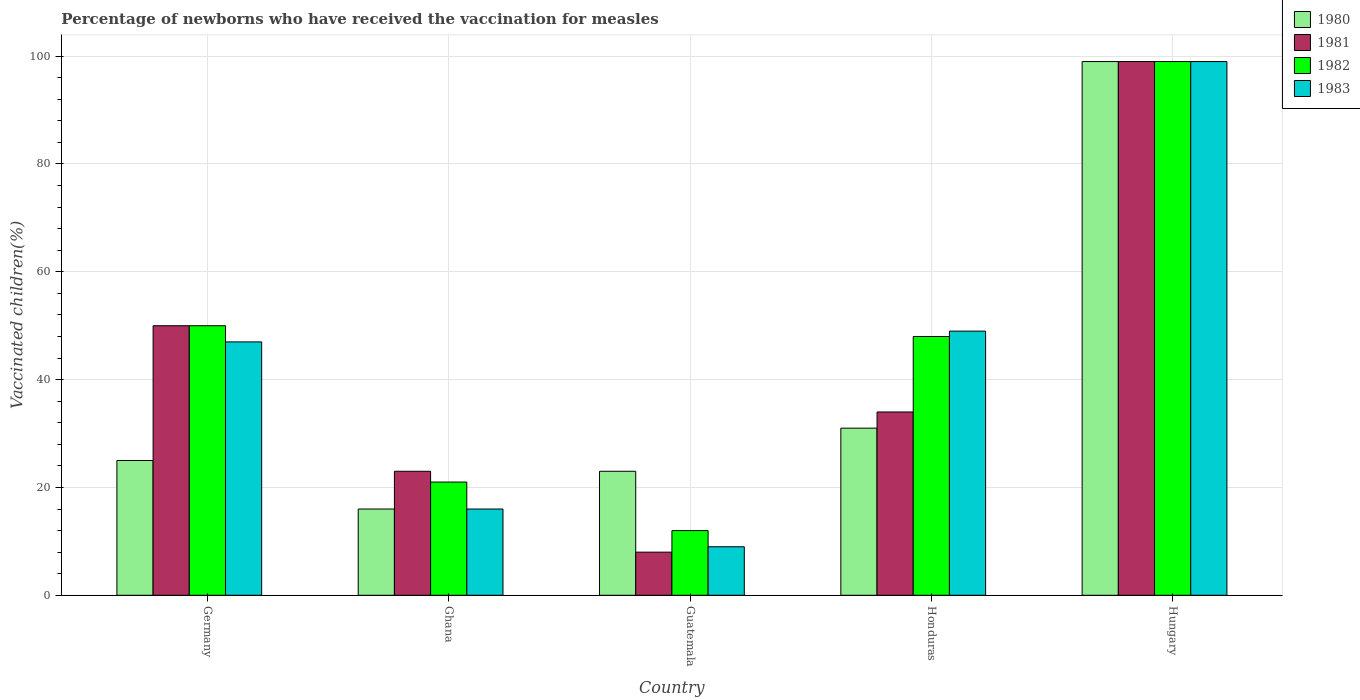How many different coloured bars are there?
Provide a succinct answer. 4. How many groups of bars are there?
Your response must be concise. 5. Are the number of bars per tick equal to the number of legend labels?
Provide a short and direct response. Yes. How many bars are there on the 5th tick from the left?
Offer a terse response. 4. How many bars are there on the 5th tick from the right?
Give a very brief answer. 4. What is the label of the 5th group of bars from the left?
Provide a succinct answer. Hungary. What is the percentage of vaccinated children in 1983 in Germany?
Your answer should be compact. 47. Across all countries, what is the maximum percentage of vaccinated children in 1981?
Give a very brief answer. 99. Across all countries, what is the minimum percentage of vaccinated children in 1983?
Provide a succinct answer. 9. In which country was the percentage of vaccinated children in 1982 maximum?
Provide a succinct answer. Hungary. In which country was the percentage of vaccinated children in 1981 minimum?
Offer a terse response. Guatemala. What is the total percentage of vaccinated children in 1982 in the graph?
Your answer should be very brief. 230. What is the difference between the percentage of vaccinated children in 1980 in Honduras and that in Hungary?
Keep it short and to the point. -68. What is the average percentage of vaccinated children in 1983 per country?
Offer a terse response. 44. What is the difference between the percentage of vaccinated children of/in 1982 and percentage of vaccinated children of/in 1980 in Honduras?
Give a very brief answer. 17. What is the ratio of the percentage of vaccinated children in 1980 in Honduras to that in Hungary?
Offer a very short reply. 0.31. In how many countries, is the percentage of vaccinated children in 1981 greater than the average percentage of vaccinated children in 1981 taken over all countries?
Ensure brevity in your answer.  2. What does the 4th bar from the left in Guatemala represents?
Your response must be concise. 1983. Is it the case that in every country, the sum of the percentage of vaccinated children in 1982 and percentage of vaccinated children in 1983 is greater than the percentage of vaccinated children in 1981?
Keep it short and to the point. Yes. Are the values on the major ticks of Y-axis written in scientific E-notation?
Your response must be concise. No. Does the graph contain grids?
Ensure brevity in your answer.  Yes. Where does the legend appear in the graph?
Provide a succinct answer. Top right. What is the title of the graph?
Your answer should be very brief. Percentage of newborns who have received the vaccination for measles. What is the label or title of the Y-axis?
Your answer should be very brief. Vaccinated children(%). What is the Vaccinated children(%) of 1980 in Germany?
Your response must be concise. 25. What is the Vaccinated children(%) in 1982 in Germany?
Provide a succinct answer. 50. What is the Vaccinated children(%) of 1983 in Germany?
Keep it short and to the point. 47. What is the Vaccinated children(%) in 1981 in Ghana?
Keep it short and to the point. 23. What is the Vaccinated children(%) in 1982 in Ghana?
Ensure brevity in your answer.  21. What is the Vaccinated children(%) of 1980 in Guatemala?
Make the answer very short. 23. What is the Vaccinated children(%) of 1981 in Honduras?
Your answer should be compact. 34. What is the Vaccinated children(%) of 1982 in Honduras?
Your response must be concise. 48. What is the Vaccinated children(%) of 1980 in Hungary?
Offer a terse response. 99. What is the Vaccinated children(%) of 1981 in Hungary?
Provide a succinct answer. 99. What is the Vaccinated children(%) in 1982 in Hungary?
Offer a terse response. 99. Across all countries, what is the maximum Vaccinated children(%) of 1981?
Make the answer very short. 99. Across all countries, what is the maximum Vaccinated children(%) in 1983?
Offer a terse response. 99. Across all countries, what is the minimum Vaccinated children(%) of 1980?
Keep it short and to the point. 16. Across all countries, what is the minimum Vaccinated children(%) in 1982?
Your answer should be compact. 12. Across all countries, what is the minimum Vaccinated children(%) in 1983?
Provide a short and direct response. 9. What is the total Vaccinated children(%) of 1980 in the graph?
Keep it short and to the point. 194. What is the total Vaccinated children(%) in 1981 in the graph?
Your response must be concise. 214. What is the total Vaccinated children(%) of 1982 in the graph?
Provide a succinct answer. 230. What is the total Vaccinated children(%) of 1983 in the graph?
Offer a very short reply. 220. What is the difference between the Vaccinated children(%) in 1981 in Germany and that in Ghana?
Keep it short and to the point. 27. What is the difference between the Vaccinated children(%) of 1983 in Germany and that in Ghana?
Make the answer very short. 31. What is the difference between the Vaccinated children(%) in 1980 in Germany and that in Honduras?
Offer a very short reply. -6. What is the difference between the Vaccinated children(%) of 1981 in Germany and that in Honduras?
Your answer should be very brief. 16. What is the difference between the Vaccinated children(%) of 1982 in Germany and that in Honduras?
Give a very brief answer. 2. What is the difference between the Vaccinated children(%) of 1983 in Germany and that in Honduras?
Your answer should be very brief. -2. What is the difference between the Vaccinated children(%) of 1980 in Germany and that in Hungary?
Give a very brief answer. -74. What is the difference between the Vaccinated children(%) of 1981 in Germany and that in Hungary?
Provide a short and direct response. -49. What is the difference between the Vaccinated children(%) in 1982 in Germany and that in Hungary?
Provide a short and direct response. -49. What is the difference between the Vaccinated children(%) of 1983 in Germany and that in Hungary?
Ensure brevity in your answer.  -52. What is the difference between the Vaccinated children(%) of 1980 in Ghana and that in Honduras?
Ensure brevity in your answer.  -15. What is the difference between the Vaccinated children(%) in 1981 in Ghana and that in Honduras?
Your answer should be compact. -11. What is the difference between the Vaccinated children(%) of 1982 in Ghana and that in Honduras?
Provide a succinct answer. -27. What is the difference between the Vaccinated children(%) in 1983 in Ghana and that in Honduras?
Ensure brevity in your answer.  -33. What is the difference between the Vaccinated children(%) in 1980 in Ghana and that in Hungary?
Provide a short and direct response. -83. What is the difference between the Vaccinated children(%) in 1981 in Ghana and that in Hungary?
Provide a succinct answer. -76. What is the difference between the Vaccinated children(%) in 1982 in Ghana and that in Hungary?
Give a very brief answer. -78. What is the difference between the Vaccinated children(%) of 1983 in Ghana and that in Hungary?
Give a very brief answer. -83. What is the difference between the Vaccinated children(%) of 1982 in Guatemala and that in Honduras?
Offer a terse response. -36. What is the difference between the Vaccinated children(%) in 1980 in Guatemala and that in Hungary?
Your answer should be compact. -76. What is the difference between the Vaccinated children(%) of 1981 in Guatemala and that in Hungary?
Make the answer very short. -91. What is the difference between the Vaccinated children(%) of 1982 in Guatemala and that in Hungary?
Offer a terse response. -87. What is the difference between the Vaccinated children(%) of 1983 in Guatemala and that in Hungary?
Provide a succinct answer. -90. What is the difference between the Vaccinated children(%) in 1980 in Honduras and that in Hungary?
Provide a short and direct response. -68. What is the difference between the Vaccinated children(%) of 1981 in Honduras and that in Hungary?
Your answer should be compact. -65. What is the difference between the Vaccinated children(%) in 1982 in Honduras and that in Hungary?
Keep it short and to the point. -51. What is the difference between the Vaccinated children(%) of 1983 in Honduras and that in Hungary?
Your answer should be compact. -50. What is the difference between the Vaccinated children(%) in 1980 in Germany and the Vaccinated children(%) in 1982 in Ghana?
Ensure brevity in your answer.  4. What is the difference between the Vaccinated children(%) in 1981 in Germany and the Vaccinated children(%) in 1982 in Ghana?
Provide a succinct answer. 29. What is the difference between the Vaccinated children(%) of 1982 in Germany and the Vaccinated children(%) of 1983 in Ghana?
Offer a terse response. 34. What is the difference between the Vaccinated children(%) in 1980 in Germany and the Vaccinated children(%) in 1982 in Guatemala?
Your response must be concise. 13. What is the difference between the Vaccinated children(%) of 1981 in Germany and the Vaccinated children(%) of 1982 in Guatemala?
Provide a succinct answer. 38. What is the difference between the Vaccinated children(%) of 1982 in Germany and the Vaccinated children(%) of 1983 in Guatemala?
Your answer should be compact. 41. What is the difference between the Vaccinated children(%) of 1980 in Germany and the Vaccinated children(%) of 1982 in Honduras?
Provide a succinct answer. -23. What is the difference between the Vaccinated children(%) in 1980 in Germany and the Vaccinated children(%) in 1983 in Honduras?
Provide a short and direct response. -24. What is the difference between the Vaccinated children(%) in 1981 in Germany and the Vaccinated children(%) in 1982 in Honduras?
Provide a short and direct response. 2. What is the difference between the Vaccinated children(%) of 1980 in Germany and the Vaccinated children(%) of 1981 in Hungary?
Your answer should be compact. -74. What is the difference between the Vaccinated children(%) in 1980 in Germany and the Vaccinated children(%) in 1982 in Hungary?
Your response must be concise. -74. What is the difference between the Vaccinated children(%) in 1980 in Germany and the Vaccinated children(%) in 1983 in Hungary?
Offer a very short reply. -74. What is the difference between the Vaccinated children(%) of 1981 in Germany and the Vaccinated children(%) of 1982 in Hungary?
Offer a terse response. -49. What is the difference between the Vaccinated children(%) of 1981 in Germany and the Vaccinated children(%) of 1983 in Hungary?
Provide a short and direct response. -49. What is the difference between the Vaccinated children(%) in 1982 in Germany and the Vaccinated children(%) in 1983 in Hungary?
Your response must be concise. -49. What is the difference between the Vaccinated children(%) of 1980 in Ghana and the Vaccinated children(%) of 1981 in Guatemala?
Your answer should be compact. 8. What is the difference between the Vaccinated children(%) in 1980 in Ghana and the Vaccinated children(%) in 1982 in Guatemala?
Make the answer very short. 4. What is the difference between the Vaccinated children(%) of 1981 in Ghana and the Vaccinated children(%) of 1982 in Guatemala?
Your answer should be compact. 11. What is the difference between the Vaccinated children(%) in 1981 in Ghana and the Vaccinated children(%) in 1983 in Guatemala?
Your answer should be very brief. 14. What is the difference between the Vaccinated children(%) of 1982 in Ghana and the Vaccinated children(%) of 1983 in Guatemala?
Offer a terse response. 12. What is the difference between the Vaccinated children(%) of 1980 in Ghana and the Vaccinated children(%) of 1982 in Honduras?
Your answer should be very brief. -32. What is the difference between the Vaccinated children(%) in 1980 in Ghana and the Vaccinated children(%) in 1983 in Honduras?
Offer a very short reply. -33. What is the difference between the Vaccinated children(%) in 1981 in Ghana and the Vaccinated children(%) in 1982 in Honduras?
Your response must be concise. -25. What is the difference between the Vaccinated children(%) of 1981 in Ghana and the Vaccinated children(%) of 1983 in Honduras?
Provide a succinct answer. -26. What is the difference between the Vaccinated children(%) of 1982 in Ghana and the Vaccinated children(%) of 1983 in Honduras?
Offer a very short reply. -28. What is the difference between the Vaccinated children(%) of 1980 in Ghana and the Vaccinated children(%) of 1981 in Hungary?
Your answer should be compact. -83. What is the difference between the Vaccinated children(%) in 1980 in Ghana and the Vaccinated children(%) in 1982 in Hungary?
Provide a succinct answer. -83. What is the difference between the Vaccinated children(%) of 1980 in Ghana and the Vaccinated children(%) of 1983 in Hungary?
Give a very brief answer. -83. What is the difference between the Vaccinated children(%) in 1981 in Ghana and the Vaccinated children(%) in 1982 in Hungary?
Offer a terse response. -76. What is the difference between the Vaccinated children(%) in 1981 in Ghana and the Vaccinated children(%) in 1983 in Hungary?
Provide a short and direct response. -76. What is the difference between the Vaccinated children(%) in 1982 in Ghana and the Vaccinated children(%) in 1983 in Hungary?
Give a very brief answer. -78. What is the difference between the Vaccinated children(%) in 1980 in Guatemala and the Vaccinated children(%) in 1981 in Honduras?
Provide a short and direct response. -11. What is the difference between the Vaccinated children(%) in 1981 in Guatemala and the Vaccinated children(%) in 1983 in Honduras?
Ensure brevity in your answer.  -41. What is the difference between the Vaccinated children(%) in 1982 in Guatemala and the Vaccinated children(%) in 1983 in Honduras?
Your response must be concise. -37. What is the difference between the Vaccinated children(%) of 1980 in Guatemala and the Vaccinated children(%) of 1981 in Hungary?
Provide a short and direct response. -76. What is the difference between the Vaccinated children(%) of 1980 in Guatemala and the Vaccinated children(%) of 1982 in Hungary?
Give a very brief answer. -76. What is the difference between the Vaccinated children(%) of 1980 in Guatemala and the Vaccinated children(%) of 1983 in Hungary?
Your answer should be very brief. -76. What is the difference between the Vaccinated children(%) of 1981 in Guatemala and the Vaccinated children(%) of 1982 in Hungary?
Offer a terse response. -91. What is the difference between the Vaccinated children(%) of 1981 in Guatemala and the Vaccinated children(%) of 1983 in Hungary?
Give a very brief answer. -91. What is the difference between the Vaccinated children(%) in 1982 in Guatemala and the Vaccinated children(%) in 1983 in Hungary?
Ensure brevity in your answer.  -87. What is the difference between the Vaccinated children(%) of 1980 in Honduras and the Vaccinated children(%) of 1981 in Hungary?
Offer a terse response. -68. What is the difference between the Vaccinated children(%) in 1980 in Honduras and the Vaccinated children(%) in 1982 in Hungary?
Make the answer very short. -68. What is the difference between the Vaccinated children(%) in 1980 in Honduras and the Vaccinated children(%) in 1983 in Hungary?
Keep it short and to the point. -68. What is the difference between the Vaccinated children(%) in 1981 in Honduras and the Vaccinated children(%) in 1982 in Hungary?
Your response must be concise. -65. What is the difference between the Vaccinated children(%) of 1981 in Honduras and the Vaccinated children(%) of 1983 in Hungary?
Your answer should be compact. -65. What is the difference between the Vaccinated children(%) of 1982 in Honduras and the Vaccinated children(%) of 1983 in Hungary?
Ensure brevity in your answer.  -51. What is the average Vaccinated children(%) in 1980 per country?
Keep it short and to the point. 38.8. What is the average Vaccinated children(%) of 1981 per country?
Provide a short and direct response. 42.8. What is the average Vaccinated children(%) in 1983 per country?
Your answer should be very brief. 44. What is the difference between the Vaccinated children(%) in 1980 and Vaccinated children(%) in 1981 in Germany?
Ensure brevity in your answer.  -25. What is the difference between the Vaccinated children(%) in 1980 and Vaccinated children(%) in 1983 in Germany?
Your response must be concise. -22. What is the difference between the Vaccinated children(%) of 1980 and Vaccinated children(%) of 1983 in Ghana?
Give a very brief answer. 0. What is the difference between the Vaccinated children(%) of 1981 and Vaccinated children(%) of 1982 in Ghana?
Provide a succinct answer. 2. What is the difference between the Vaccinated children(%) of 1980 and Vaccinated children(%) of 1981 in Guatemala?
Give a very brief answer. 15. What is the difference between the Vaccinated children(%) of 1980 and Vaccinated children(%) of 1982 in Guatemala?
Your answer should be very brief. 11. What is the difference between the Vaccinated children(%) of 1982 and Vaccinated children(%) of 1983 in Guatemala?
Provide a short and direct response. 3. What is the difference between the Vaccinated children(%) in 1980 and Vaccinated children(%) in 1981 in Honduras?
Ensure brevity in your answer.  -3. What is the difference between the Vaccinated children(%) of 1981 and Vaccinated children(%) of 1983 in Honduras?
Your answer should be compact. -15. What is the difference between the Vaccinated children(%) of 1980 and Vaccinated children(%) of 1982 in Hungary?
Your answer should be compact. 0. What is the difference between the Vaccinated children(%) of 1980 and Vaccinated children(%) of 1983 in Hungary?
Offer a very short reply. 0. What is the difference between the Vaccinated children(%) in 1981 and Vaccinated children(%) in 1982 in Hungary?
Keep it short and to the point. 0. What is the difference between the Vaccinated children(%) in 1981 and Vaccinated children(%) in 1983 in Hungary?
Ensure brevity in your answer.  0. What is the difference between the Vaccinated children(%) of 1982 and Vaccinated children(%) of 1983 in Hungary?
Give a very brief answer. 0. What is the ratio of the Vaccinated children(%) in 1980 in Germany to that in Ghana?
Ensure brevity in your answer.  1.56. What is the ratio of the Vaccinated children(%) in 1981 in Germany to that in Ghana?
Make the answer very short. 2.17. What is the ratio of the Vaccinated children(%) in 1982 in Germany to that in Ghana?
Make the answer very short. 2.38. What is the ratio of the Vaccinated children(%) of 1983 in Germany to that in Ghana?
Your answer should be very brief. 2.94. What is the ratio of the Vaccinated children(%) of 1980 in Germany to that in Guatemala?
Offer a terse response. 1.09. What is the ratio of the Vaccinated children(%) in 1981 in Germany to that in Guatemala?
Your response must be concise. 6.25. What is the ratio of the Vaccinated children(%) of 1982 in Germany to that in Guatemala?
Your response must be concise. 4.17. What is the ratio of the Vaccinated children(%) of 1983 in Germany to that in Guatemala?
Your answer should be very brief. 5.22. What is the ratio of the Vaccinated children(%) of 1980 in Germany to that in Honduras?
Provide a short and direct response. 0.81. What is the ratio of the Vaccinated children(%) in 1981 in Germany to that in Honduras?
Your answer should be very brief. 1.47. What is the ratio of the Vaccinated children(%) of 1982 in Germany to that in Honduras?
Provide a short and direct response. 1.04. What is the ratio of the Vaccinated children(%) in 1983 in Germany to that in Honduras?
Give a very brief answer. 0.96. What is the ratio of the Vaccinated children(%) in 1980 in Germany to that in Hungary?
Your answer should be very brief. 0.25. What is the ratio of the Vaccinated children(%) in 1981 in Germany to that in Hungary?
Ensure brevity in your answer.  0.51. What is the ratio of the Vaccinated children(%) in 1982 in Germany to that in Hungary?
Offer a very short reply. 0.51. What is the ratio of the Vaccinated children(%) in 1983 in Germany to that in Hungary?
Keep it short and to the point. 0.47. What is the ratio of the Vaccinated children(%) in 1980 in Ghana to that in Guatemala?
Offer a very short reply. 0.7. What is the ratio of the Vaccinated children(%) in 1981 in Ghana to that in Guatemala?
Ensure brevity in your answer.  2.88. What is the ratio of the Vaccinated children(%) in 1983 in Ghana to that in Guatemala?
Your response must be concise. 1.78. What is the ratio of the Vaccinated children(%) of 1980 in Ghana to that in Honduras?
Give a very brief answer. 0.52. What is the ratio of the Vaccinated children(%) of 1981 in Ghana to that in Honduras?
Your answer should be very brief. 0.68. What is the ratio of the Vaccinated children(%) in 1982 in Ghana to that in Honduras?
Provide a succinct answer. 0.44. What is the ratio of the Vaccinated children(%) in 1983 in Ghana to that in Honduras?
Your response must be concise. 0.33. What is the ratio of the Vaccinated children(%) of 1980 in Ghana to that in Hungary?
Your response must be concise. 0.16. What is the ratio of the Vaccinated children(%) of 1981 in Ghana to that in Hungary?
Provide a succinct answer. 0.23. What is the ratio of the Vaccinated children(%) in 1982 in Ghana to that in Hungary?
Provide a short and direct response. 0.21. What is the ratio of the Vaccinated children(%) of 1983 in Ghana to that in Hungary?
Provide a short and direct response. 0.16. What is the ratio of the Vaccinated children(%) of 1980 in Guatemala to that in Honduras?
Keep it short and to the point. 0.74. What is the ratio of the Vaccinated children(%) of 1981 in Guatemala to that in Honduras?
Keep it short and to the point. 0.24. What is the ratio of the Vaccinated children(%) of 1983 in Guatemala to that in Honduras?
Make the answer very short. 0.18. What is the ratio of the Vaccinated children(%) in 1980 in Guatemala to that in Hungary?
Your response must be concise. 0.23. What is the ratio of the Vaccinated children(%) of 1981 in Guatemala to that in Hungary?
Your answer should be compact. 0.08. What is the ratio of the Vaccinated children(%) in 1982 in Guatemala to that in Hungary?
Provide a succinct answer. 0.12. What is the ratio of the Vaccinated children(%) of 1983 in Guatemala to that in Hungary?
Provide a succinct answer. 0.09. What is the ratio of the Vaccinated children(%) in 1980 in Honduras to that in Hungary?
Make the answer very short. 0.31. What is the ratio of the Vaccinated children(%) of 1981 in Honduras to that in Hungary?
Your answer should be very brief. 0.34. What is the ratio of the Vaccinated children(%) of 1982 in Honduras to that in Hungary?
Your answer should be compact. 0.48. What is the ratio of the Vaccinated children(%) in 1983 in Honduras to that in Hungary?
Offer a very short reply. 0.49. What is the difference between the highest and the second highest Vaccinated children(%) of 1981?
Your answer should be compact. 49. What is the difference between the highest and the second highest Vaccinated children(%) in 1982?
Provide a succinct answer. 49. What is the difference between the highest and the lowest Vaccinated children(%) of 1980?
Give a very brief answer. 83. What is the difference between the highest and the lowest Vaccinated children(%) in 1981?
Offer a very short reply. 91. What is the difference between the highest and the lowest Vaccinated children(%) in 1982?
Offer a terse response. 87. What is the difference between the highest and the lowest Vaccinated children(%) of 1983?
Offer a very short reply. 90. 